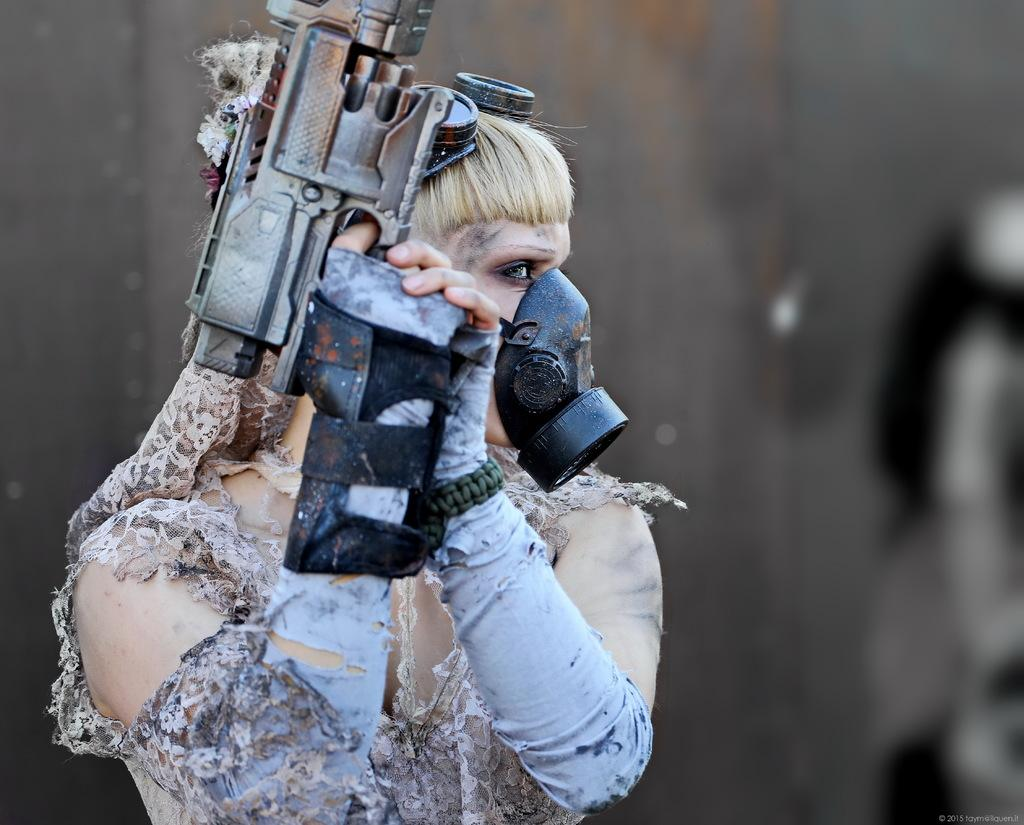Who is the main subject in the image? There is a girl in the image. What is the girl holding in the image? The girl is holding a gun. What type of clothing is the girl wearing on her hands? The girl is wearing gloves. What type of clothing is the girl wearing on her face? The girl is wearing a mask. What can be seen in the background of the image? There is a wall in the background of the image. What is the caption of the image? There is no caption present in the image. What type of part is visible on the girl's body in the image? There is no specific part of the girl's body mentioned in the provided facts, so it cannot be determined from the image. 